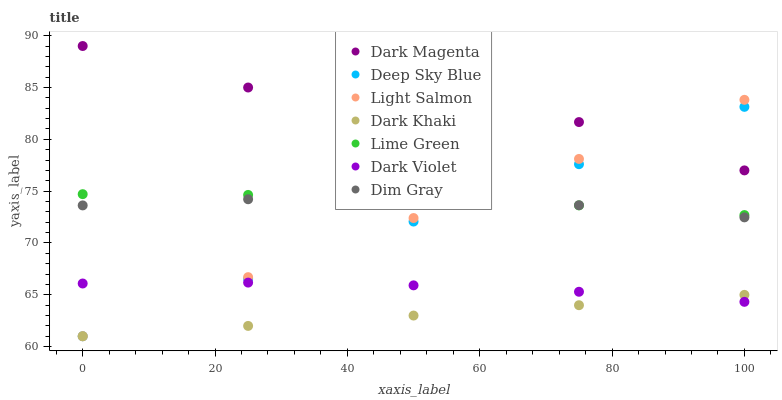Does Dark Khaki have the minimum area under the curve?
Answer yes or no. Yes. Does Dark Magenta have the maximum area under the curve?
Answer yes or no. Yes. Does Dim Gray have the minimum area under the curve?
Answer yes or no. No. Does Dim Gray have the maximum area under the curve?
Answer yes or no. No. Is Deep Sky Blue the smoothest?
Answer yes or no. Yes. Is Dark Magenta the roughest?
Answer yes or no. Yes. Is Dim Gray the smoothest?
Answer yes or no. No. Is Dim Gray the roughest?
Answer yes or no. No. Does Light Salmon have the lowest value?
Answer yes or no. Yes. Does Dim Gray have the lowest value?
Answer yes or no. No. Does Dark Magenta have the highest value?
Answer yes or no. Yes. Does Dim Gray have the highest value?
Answer yes or no. No. Is Dark Khaki less than Lime Green?
Answer yes or no. Yes. Is Lime Green greater than Dark Khaki?
Answer yes or no. Yes. Does Dim Gray intersect Light Salmon?
Answer yes or no. Yes. Is Dim Gray less than Light Salmon?
Answer yes or no. No. Is Dim Gray greater than Light Salmon?
Answer yes or no. No. Does Dark Khaki intersect Lime Green?
Answer yes or no. No. 